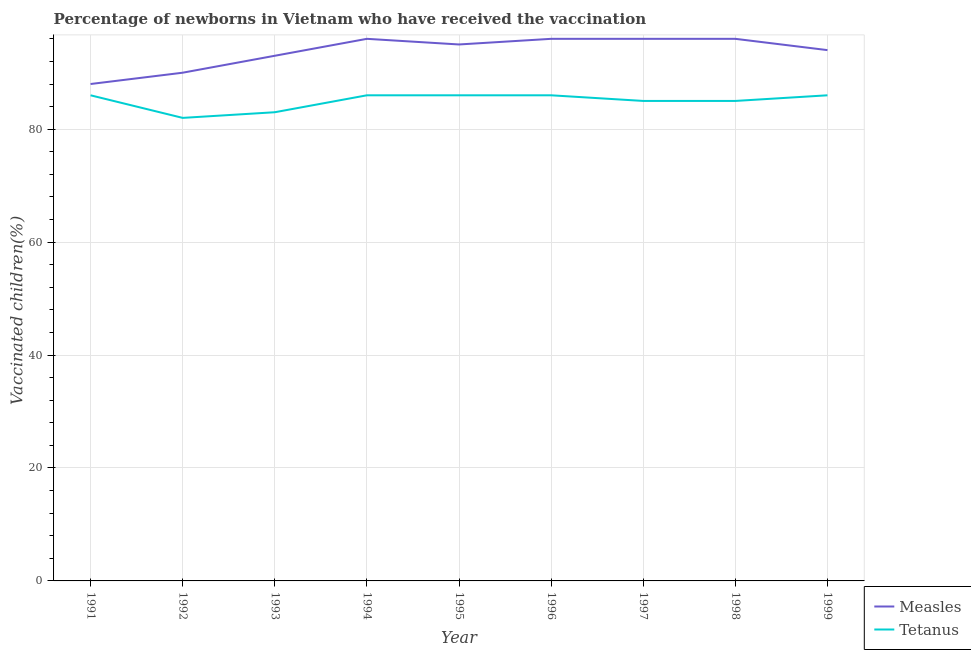How many different coloured lines are there?
Provide a succinct answer. 2. Is the number of lines equal to the number of legend labels?
Your answer should be very brief. Yes. What is the percentage of newborns who received vaccination for measles in 1999?
Provide a short and direct response. 94. Across all years, what is the maximum percentage of newborns who received vaccination for measles?
Offer a very short reply. 96. Across all years, what is the minimum percentage of newborns who received vaccination for tetanus?
Offer a terse response. 82. In which year was the percentage of newborns who received vaccination for tetanus maximum?
Provide a succinct answer. 1991. In which year was the percentage of newborns who received vaccination for tetanus minimum?
Provide a short and direct response. 1992. What is the total percentage of newborns who received vaccination for tetanus in the graph?
Ensure brevity in your answer.  765. What is the difference between the percentage of newborns who received vaccination for measles in 1993 and that in 1995?
Make the answer very short. -2. What is the difference between the percentage of newborns who received vaccination for tetanus in 1997 and the percentage of newborns who received vaccination for measles in 1992?
Your answer should be very brief. -5. What is the average percentage of newborns who received vaccination for measles per year?
Ensure brevity in your answer.  93.78. In the year 1993, what is the difference between the percentage of newborns who received vaccination for tetanus and percentage of newborns who received vaccination for measles?
Keep it short and to the point. -10. In how many years, is the percentage of newborns who received vaccination for measles greater than 80 %?
Provide a short and direct response. 9. What is the ratio of the percentage of newborns who received vaccination for measles in 1994 to that in 1997?
Your answer should be compact. 1. Is the percentage of newborns who received vaccination for tetanus in 1992 less than that in 1998?
Your answer should be very brief. Yes. What is the difference between the highest and the second highest percentage of newborns who received vaccination for tetanus?
Give a very brief answer. 0. What is the difference between the highest and the lowest percentage of newborns who received vaccination for measles?
Ensure brevity in your answer.  8. Is the sum of the percentage of newborns who received vaccination for measles in 1993 and 1997 greater than the maximum percentage of newborns who received vaccination for tetanus across all years?
Ensure brevity in your answer.  Yes. Does the percentage of newborns who received vaccination for tetanus monotonically increase over the years?
Your answer should be compact. No. How many lines are there?
Your response must be concise. 2. Does the graph contain grids?
Make the answer very short. Yes. What is the title of the graph?
Offer a terse response. Percentage of newborns in Vietnam who have received the vaccination. Does "Export" appear as one of the legend labels in the graph?
Keep it short and to the point. No. What is the label or title of the X-axis?
Ensure brevity in your answer.  Year. What is the label or title of the Y-axis?
Give a very brief answer. Vaccinated children(%)
. What is the Vaccinated children(%)
 in Tetanus in 1991?
Ensure brevity in your answer.  86. What is the Vaccinated children(%)
 in Measles in 1992?
Offer a terse response. 90. What is the Vaccinated children(%)
 in Tetanus in 1992?
Your response must be concise. 82. What is the Vaccinated children(%)
 of Measles in 1993?
Offer a terse response. 93. What is the Vaccinated children(%)
 of Tetanus in 1993?
Your answer should be very brief. 83. What is the Vaccinated children(%)
 in Measles in 1994?
Keep it short and to the point. 96. What is the Vaccinated children(%)
 of Measles in 1996?
Ensure brevity in your answer.  96. What is the Vaccinated children(%)
 in Tetanus in 1996?
Offer a terse response. 86. What is the Vaccinated children(%)
 of Measles in 1997?
Your answer should be very brief. 96. What is the Vaccinated children(%)
 in Measles in 1998?
Keep it short and to the point. 96. What is the Vaccinated children(%)
 of Measles in 1999?
Offer a very short reply. 94. Across all years, what is the maximum Vaccinated children(%)
 of Measles?
Keep it short and to the point. 96. Across all years, what is the minimum Vaccinated children(%)
 in Measles?
Provide a short and direct response. 88. What is the total Vaccinated children(%)
 of Measles in the graph?
Provide a short and direct response. 844. What is the total Vaccinated children(%)
 in Tetanus in the graph?
Ensure brevity in your answer.  765. What is the difference between the Vaccinated children(%)
 of Tetanus in 1991 and that in 1992?
Give a very brief answer. 4. What is the difference between the Vaccinated children(%)
 of Measles in 1991 and that in 1994?
Give a very brief answer. -8. What is the difference between the Vaccinated children(%)
 in Tetanus in 1991 and that in 1994?
Your answer should be very brief. 0. What is the difference between the Vaccinated children(%)
 of Measles in 1991 and that in 1995?
Make the answer very short. -7. What is the difference between the Vaccinated children(%)
 in Tetanus in 1991 and that in 1995?
Provide a succinct answer. 0. What is the difference between the Vaccinated children(%)
 of Tetanus in 1991 and that in 1996?
Offer a terse response. 0. What is the difference between the Vaccinated children(%)
 in Measles in 1991 and that in 1997?
Make the answer very short. -8. What is the difference between the Vaccinated children(%)
 in Tetanus in 1991 and that in 1997?
Your response must be concise. 1. What is the difference between the Vaccinated children(%)
 of Measles in 1991 and that in 1998?
Give a very brief answer. -8. What is the difference between the Vaccinated children(%)
 of Tetanus in 1991 and that in 1998?
Your response must be concise. 1. What is the difference between the Vaccinated children(%)
 of Measles in 1991 and that in 1999?
Your answer should be compact. -6. What is the difference between the Vaccinated children(%)
 of Tetanus in 1992 and that in 1994?
Make the answer very short. -4. What is the difference between the Vaccinated children(%)
 in Measles in 1992 and that in 1996?
Give a very brief answer. -6. What is the difference between the Vaccinated children(%)
 in Tetanus in 1992 and that in 1997?
Make the answer very short. -3. What is the difference between the Vaccinated children(%)
 of Measles in 1992 and that in 1998?
Your response must be concise. -6. What is the difference between the Vaccinated children(%)
 of Tetanus in 1992 and that in 1998?
Your response must be concise. -3. What is the difference between the Vaccinated children(%)
 in Measles in 1992 and that in 1999?
Give a very brief answer. -4. What is the difference between the Vaccinated children(%)
 of Measles in 1993 and that in 1994?
Your response must be concise. -3. What is the difference between the Vaccinated children(%)
 in Tetanus in 1993 and that in 1994?
Your answer should be compact. -3. What is the difference between the Vaccinated children(%)
 in Measles in 1993 and that in 1995?
Your response must be concise. -2. What is the difference between the Vaccinated children(%)
 of Measles in 1993 and that in 1996?
Offer a terse response. -3. What is the difference between the Vaccinated children(%)
 of Measles in 1993 and that in 1997?
Your response must be concise. -3. What is the difference between the Vaccinated children(%)
 in Tetanus in 1993 and that in 1998?
Your response must be concise. -2. What is the difference between the Vaccinated children(%)
 of Measles in 1993 and that in 1999?
Your response must be concise. -1. What is the difference between the Vaccinated children(%)
 of Measles in 1994 and that in 1995?
Offer a terse response. 1. What is the difference between the Vaccinated children(%)
 in Tetanus in 1994 and that in 1995?
Your answer should be compact. 0. What is the difference between the Vaccinated children(%)
 of Measles in 1994 and that in 1996?
Make the answer very short. 0. What is the difference between the Vaccinated children(%)
 of Tetanus in 1994 and that in 1996?
Offer a terse response. 0. What is the difference between the Vaccinated children(%)
 in Measles in 1994 and that in 1997?
Ensure brevity in your answer.  0. What is the difference between the Vaccinated children(%)
 of Tetanus in 1994 and that in 1997?
Your answer should be compact. 1. What is the difference between the Vaccinated children(%)
 in Measles in 1994 and that in 1999?
Ensure brevity in your answer.  2. What is the difference between the Vaccinated children(%)
 of Tetanus in 1994 and that in 1999?
Offer a very short reply. 0. What is the difference between the Vaccinated children(%)
 in Tetanus in 1995 and that in 1996?
Keep it short and to the point. 0. What is the difference between the Vaccinated children(%)
 in Tetanus in 1995 and that in 1998?
Provide a short and direct response. 1. What is the difference between the Vaccinated children(%)
 of Measles in 1995 and that in 1999?
Offer a terse response. 1. What is the difference between the Vaccinated children(%)
 of Tetanus in 1995 and that in 1999?
Make the answer very short. 0. What is the difference between the Vaccinated children(%)
 in Measles in 1996 and that in 1997?
Ensure brevity in your answer.  0. What is the difference between the Vaccinated children(%)
 of Tetanus in 1996 and that in 1999?
Offer a very short reply. 0. What is the difference between the Vaccinated children(%)
 of Measles in 1997 and that in 1999?
Your answer should be very brief. 2. What is the difference between the Vaccinated children(%)
 of Tetanus in 1997 and that in 1999?
Provide a succinct answer. -1. What is the difference between the Vaccinated children(%)
 of Measles in 1998 and that in 1999?
Provide a succinct answer. 2. What is the difference between the Vaccinated children(%)
 of Measles in 1991 and the Vaccinated children(%)
 of Tetanus in 1992?
Offer a very short reply. 6. What is the difference between the Vaccinated children(%)
 of Measles in 1991 and the Vaccinated children(%)
 of Tetanus in 1994?
Offer a very short reply. 2. What is the difference between the Vaccinated children(%)
 in Measles in 1991 and the Vaccinated children(%)
 in Tetanus in 1996?
Provide a short and direct response. 2. What is the difference between the Vaccinated children(%)
 in Measles in 1992 and the Vaccinated children(%)
 in Tetanus in 1993?
Your answer should be very brief. 7. What is the difference between the Vaccinated children(%)
 of Measles in 1992 and the Vaccinated children(%)
 of Tetanus in 1994?
Make the answer very short. 4. What is the difference between the Vaccinated children(%)
 in Measles in 1992 and the Vaccinated children(%)
 in Tetanus in 1997?
Ensure brevity in your answer.  5. What is the difference between the Vaccinated children(%)
 in Measles in 1992 and the Vaccinated children(%)
 in Tetanus in 1999?
Make the answer very short. 4. What is the difference between the Vaccinated children(%)
 of Measles in 1993 and the Vaccinated children(%)
 of Tetanus in 1996?
Your answer should be compact. 7. What is the difference between the Vaccinated children(%)
 in Measles in 1993 and the Vaccinated children(%)
 in Tetanus in 1997?
Offer a very short reply. 8. What is the difference between the Vaccinated children(%)
 of Measles in 1993 and the Vaccinated children(%)
 of Tetanus in 1998?
Keep it short and to the point. 8. What is the difference between the Vaccinated children(%)
 of Measles in 1993 and the Vaccinated children(%)
 of Tetanus in 1999?
Keep it short and to the point. 7. What is the difference between the Vaccinated children(%)
 of Measles in 1994 and the Vaccinated children(%)
 of Tetanus in 1998?
Offer a terse response. 11. What is the difference between the Vaccinated children(%)
 of Measles in 1995 and the Vaccinated children(%)
 of Tetanus in 1996?
Give a very brief answer. 9. What is the difference between the Vaccinated children(%)
 of Measles in 1995 and the Vaccinated children(%)
 of Tetanus in 1997?
Your answer should be compact. 10. What is the difference between the Vaccinated children(%)
 in Measles in 1995 and the Vaccinated children(%)
 in Tetanus in 1998?
Offer a terse response. 10. What is the difference between the Vaccinated children(%)
 in Measles in 1996 and the Vaccinated children(%)
 in Tetanus in 1998?
Give a very brief answer. 11. What is the difference between the Vaccinated children(%)
 in Measles in 1996 and the Vaccinated children(%)
 in Tetanus in 1999?
Your answer should be very brief. 10. What is the average Vaccinated children(%)
 of Measles per year?
Provide a succinct answer. 93.78. What is the average Vaccinated children(%)
 of Tetanus per year?
Make the answer very short. 85. In the year 1991, what is the difference between the Vaccinated children(%)
 in Measles and Vaccinated children(%)
 in Tetanus?
Keep it short and to the point. 2. In the year 1993, what is the difference between the Vaccinated children(%)
 in Measles and Vaccinated children(%)
 in Tetanus?
Give a very brief answer. 10. In the year 1994, what is the difference between the Vaccinated children(%)
 of Measles and Vaccinated children(%)
 of Tetanus?
Your answer should be compact. 10. In the year 1995, what is the difference between the Vaccinated children(%)
 of Measles and Vaccinated children(%)
 of Tetanus?
Give a very brief answer. 9. In the year 1996, what is the difference between the Vaccinated children(%)
 of Measles and Vaccinated children(%)
 of Tetanus?
Provide a succinct answer. 10. In the year 1998, what is the difference between the Vaccinated children(%)
 of Measles and Vaccinated children(%)
 of Tetanus?
Your answer should be very brief. 11. In the year 1999, what is the difference between the Vaccinated children(%)
 of Measles and Vaccinated children(%)
 of Tetanus?
Keep it short and to the point. 8. What is the ratio of the Vaccinated children(%)
 in Measles in 1991 to that in 1992?
Provide a short and direct response. 0.98. What is the ratio of the Vaccinated children(%)
 of Tetanus in 1991 to that in 1992?
Offer a very short reply. 1.05. What is the ratio of the Vaccinated children(%)
 in Measles in 1991 to that in 1993?
Provide a succinct answer. 0.95. What is the ratio of the Vaccinated children(%)
 of Tetanus in 1991 to that in 1993?
Make the answer very short. 1.04. What is the ratio of the Vaccinated children(%)
 of Tetanus in 1991 to that in 1994?
Provide a succinct answer. 1. What is the ratio of the Vaccinated children(%)
 in Measles in 1991 to that in 1995?
Make the answer very short. 0.93. What is the ratio of the Vaccinated children(%)
 in Tetanus in 1991 to that in 1995?
Offer a terse response. 1. What is the ratio of the Vaccinated children(%)
 of Measles in 1991 to that in 1996?
Your answer should be compact. 0.92. What is the ratio of the Vaccinated children(%)
 of Tetanus in 1991 to that in 1997?
Your answer should be very brief. 1.01. What is the ratio of the Vaccinated children(%)
 in Measles in 1991 to that in 1998?
Your response must be concise. 0.92. What is the ratio of the Vaccinated children(%)
 in Tetanus in 1991 to that in 1998?
Make the answer very short. 1.01. What is the ratio of the Vaccinated children(%)
 of Measles in 1991 to that in 1999?
Your answer should be very brief. 0.94. What is the ratio of the Vaccinated children(%)
 of Tetanus in 1992 to that in 1994?
Offer a very short reply. 0.95. What is the ratio of the Vaccinated children(%)
 in Tetanus in 1992 to that in 1995?
Offer a very short reply. 0.95. What is the ratio of the Vaccinated children(%)
 in Tetanus in 1992 to that in 1996?
Offer a terse response. 0.95. What is the ratio of the Vaccinated children(%)
 of Tetanus in 1992 to that in 1997?
Offer a terse response. 0.96. What is the ratio of the Vaccinated children(%)
 in Tetanus in 1992 to that in 1998?
Your answer should be very brief. 0.96. What is the ratio of the Vaccinated children(%)
 in Measles in 1992 to that in 1999?
Offer a terse response. 0.96. What is the ratio of the Vaccinated children(%)
 of Tetanus in 1992 to that in 1999?
Your response must be concise. 0.95. What is the ratio of the Vaccinated children(%)
 of Measles in 1993 to that in 1994?
Offer a very short reply. 0.97. What is the ratio of the Vaccinated children(%)
 in Tetanus in 1993 to that in 1994?
Provide a short and direct response. 0.97. What is the ratio of the Vaccinated children(%)
 of Measles in 1993 to that in 1995?
Make the answer very short. 0.98. What is the ratio of the Vaccinated children(%)
 in Tetanus in 1993 to that in 1995?
Give a very brief answer. 0.97. What is the ratio of the Vaccinated children(%)
 in Measles in 1993 to that in 1996?
Ensure brevity in your answer.  0.97. What is the ratio of the Vaccinated children(%)
 of Tetanus in 1993 to that in 1996?
Your answer should be very brief. 0.97. What is the ratio of the Vaccinated children(%)
 in Measles in 1993 to that in 1997?
Give a very brief answer. 0.97. What is the ratio of the Vaccinated children(%)
 in Tetanus in 1993 to that in 1997?
Make the answer very short. 0.98. What is the ratio of the Vaccinated children(%)
 in Measles in 1993 to that in 1998?
Keep it short and to the point. 0.97. What is the ratio of the Vaccinated children(%)
 of Tetanus in 1993 to that in 1998?
Keep it short and to the point. 0.98. What is the ratio of the Vaccinated children(%)
 of Tetanus in 1993 to that in 1999?
Ensure brevity in your answer.  0.97. What is the ratio of the Vaccinated children(%)
 in Measles in 1994 to that in 1995?
Your answer should be compact. 1.01. What is the ratio of the Vaccinated children(%)
 in Tetanus in 1994 to that in 1995?
Your answer should be compact. 1. What is the ratio of the Vaccinated children(%)
 in Measles in 1994 to that in 1996?
Provide a succinct answer. 1. What is the ratio of the Vaccinated children(%)
 of Tetanus in 1994 to that in 1997?
Provide a succinct answer. 1.01. What is the ratio of the Vaccinated children(%)
 of Measles in 1994 to that in 1998?
Keep it short and to the point. 1. What is the ratio of the Vaccinated children(%)
 of Tetanus in 1994 to that in 1998?
Your answer should be compact. 1.01. What is the ratio of the Vaccinated children(%)
 of Measles in 1994 to that in 1999?
Your answer should be very brief. 1.02. What is the ratio of the Vaccinated children(%)
 of Tetanus in 1995 to that in 1997?
Make the answer very short. 1.01. What is the ratio of the Vaccinated children(%)
 in Tetanus in 1995 to that in 1998?
Offer a very short reply. 1.01. What is the ratio of the Vaccinated children(%)
 of Measles in 1995 to that in 1999?
Give a very brief answer. 1.01. What is the ratio of the Vaccinated children(%)
 in Tetanus in 1995 to that in 1999?
Offer a terse response. 1. What is the ratio of the Vaccinated children(%)
 of Measles in 1996 to that in 1997?
Your response must be concise. 1. What is the ratio of the Vaccinated children(%)
 in Tetanus in 1996 to that in 1997?
Keep it short and to the point. 1.01. What is the ratio of the Vaccinated children(%)
 in Measles in 1996 to that in 1998?
Provide a short and direct response. 1. What is the ratio of the Vaccinated children(%)
 in Tetanus in 1996 to that in 1998?
Keep it short and to the point. 1.01. What is the ratio of the Vaccinated children(%)
 in Measles in 1996 to that in 1999?
Give a very brief answer. 1.02. What is the ratio of the Vaccinated children(%)
 of Tetanus in 1996 to that in 1999?
Provide a short and direct response. 1. What is the ratio of the Vaccinated children(%)
 in Measles in 1997 to that in 1998?
Provide a short and direct response. 1. What is the ratio of the Vaccinated children(%)
 of Tetanus in 1997 to that in 1998?
Ensure brevity in your answer.  1. What is the ratio of the Vaccinated children(%)
 of Measles in 1997 to that in 1999?
Your response must be concise. 1.02. What is the ratio of the Vaccinated children(%)
 in Tetanus in 1997 to that in 1999?
Ensure brevity in your answer.  0.99. What is the ratio of the Vaccinated children(%)
 of Measles in 1998 to that in 1999?
Ensure brevity in your answer.  1.02. What is the ratio of the Vaccinated children(%)
 of Tetanus in 1998 to that in 1999?
Offer a terse response. 0.99. What is the difference between the highest and the second highest Vaccinated children(%)
 in Tetanus?
Your answer should be compact. 0. What is the difference between the highest and the lowest Vaccinated children(%)
 of Measles?
Keep it short and to the point. 8. What is the difference between the highest and the lowest Vaccinated children(%)
 of Tetanus?
Your response must be concise. 4. 